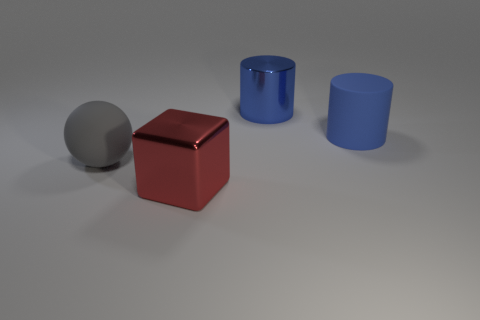Are any gray matte objects visible?
Ensure brevity in your answer.  Yes. Are there more big red shiny objects to the right of the red shiny cube than matte objects on the left side of the big gray rubber ball?
Make the answer very short. No. What is the color of the metallic object in front of the big blue cylinder that is in front of the metallic cylinder?
Give a very brief answer. Red. Are there any other large metallic cylinders that have the same color as the shiny cylinder?
Keep it short and to the point. No. How big is the blue cylinder that is right of the big cylinder that is behind the blue cylinder to the right of the large blue metallic thing?
Provide a succinct answer. Large. What is the shape of the big red shiny object?
Keep it short and to the point. Cube. What is the size of the rubber cylinder that is the same color as the shiny cylinder?
Provide a short and direct response. Large. How many metal things are in front of the large matte thing to the left of the red object?
Your answer should be compact. 1. How many other objects are the same material as the gray ball?
Keep it short and to the point. 1. Do the object to the left of the red block and the red block that is to the left of the metallic cylinder have the same material?
Ensure brevity in your answer.  No. 